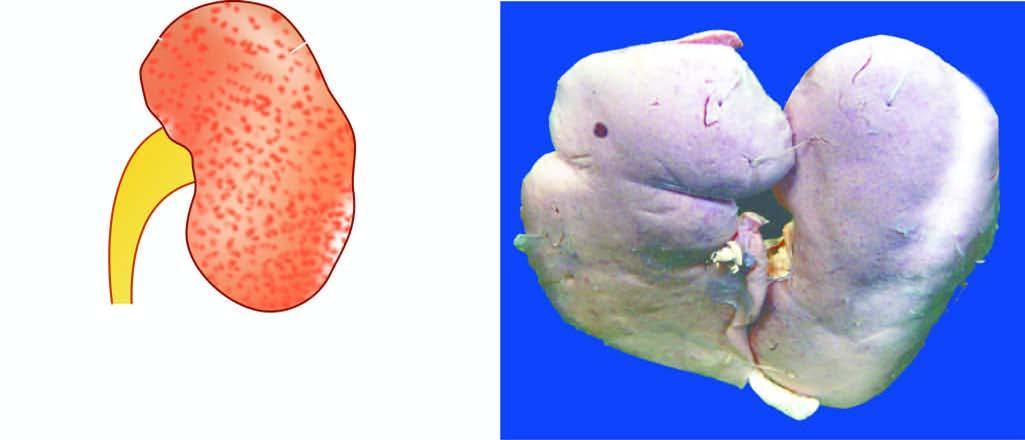s small contracted kidney in chronic hypertension benign nephrosclerosis?
Answer the question using a single word or phrase. Yes 